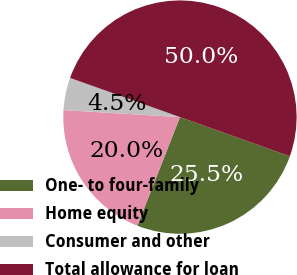<chart> <loc_0><loc_0><loc_500><loc_500><pie_chart><fcel>One- to four-family<fcel>Home equity<fcel>Consumer and other<fcel>Total allowance for loan<nl><fcel>25.5%<fcel>20.0%<fcel>4.5%<fcel>50.0%<nl></chart> 